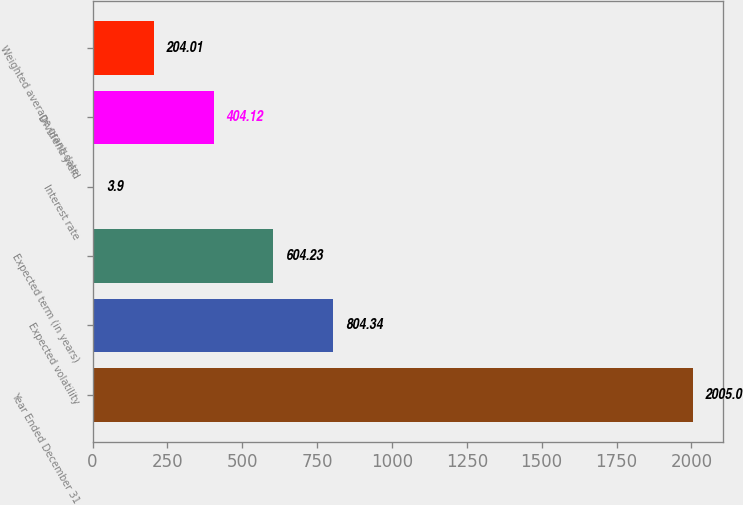Convert chart. <chart><loc_0><loc_0><loc_500><loc_500><bar_chart><fcel>Year Ended December 31<fcel>Expected volatility<fcel>Expected term (in years)<fcel>Interest rate<fcel>Dividend yield<fcel>Weighted average grant-date<nl><fcel>2005<fcel>804.34<fcel>604.23<fcel>3.9<fcel>404.12<fcel>204.01<nl></chart> 